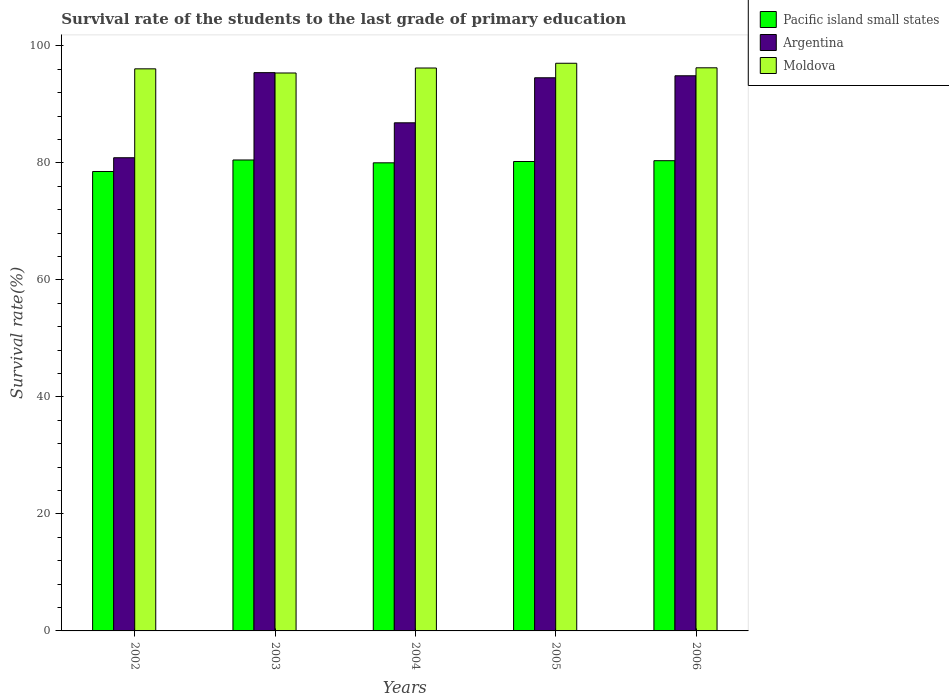How many different coloured bars are there?
Give a very brief answer. 3. Are the number of bars on each tick of the X-axis equal?
Your response must be concise. Yes. How many bars are there on the 3rd tick from the right?
Make the answer very short. 3. What is the label of the 2nd group of bars from the left?
Provide a short and direct response. 2003. In how many cases, is the number of bars for a given year not equal to the number of legend labels?
Offer a terse response. 0. What is the survival rate of the students in Pacific island small states in 2005?
Offer a very short reply. 80.23. Across all years, what is the maximum survival rate of the students in Argentina?
Keep it short and to the point. 95.42. Across all years, what is the minimum survival rate of the students in Moldova?
Give a very brief answer. 95.36. What is the total survival rate of the students in Moldova in the graph?
Ensure brevity in your answer.  480.9. What is the difference between the survival rate of the students in Argentina in 2003 and that in 2004?
Offer a very short reply. 8.57. What is the difference between the survival rate of the students in Argentina in 2003 and the survival rate of the students in Moldova in 2006?
Keep it short and to the point. -0.83. What is the average survival rate of the students in Pacific island small states per year?
Make the answer very short. 79.92. In the year 2005, what is the difference between the survival rate of the students in Moldova and survival rate of the students in Argentina?
Provide a short and direct response. 2.48. What is the ratio of the survival rate of the students in Pacific island small states in 2004 to that in 2005?
Your response must be concise. 1. Is the survival rate of the students in Pacific island small states in 2003 less than that in 2005?
Your answer should be compact. No. What is the difference between the highest and the second highest survival rate of the students in Argentina?
Your answer should be very brief. 0.53. What is the difference between the highest and the lowest survival rate of the students in Moldova?
Give a very brief answer. 1.66. In how many years, is the survival rate of the students in Pacific island small states greater than the average survival rate of the students in Pacific island small states taken over all years?
Your response must be concise. 4. What does the 1st bar from the left in 2006 represents?
Provide a short and direct response. Pacific island small states. What does the 2nd bar from the right in 2003 represents?
Offer a terse response. Argentina. Is it the case that in every year, the sum of the survival rate of the students in Argentina and survival rate of the students in Pacific island small states is greater than the survival rate of the students in Moldova?
Offer a very short reply. Yes. How many years are there in the graph?
Your answer should be very brief. 5. What is the difference between two consecutive major ticks on the Y-axis?
Your response must be concise. 20. Are the values on the major ticks of Y-axis written in scientific E-notation?
Provide a short and direct response. No. Does the graph contain any zero values?
Your response must be concise. No. Does the graph contain grids?
Your answer should be compact. No. Where does the legend appear in the graph?
Ensure brevity in your answer.  Top right. How many legend labels are there?
Offer a very short reply. 3. What is the title of the graph?
Give a very brief answer. Survival rate of the students to the last grade of primary education. What is the label or title of the Y-axis?
Your answer should be compact. Survival rate(%). What is the Survival rate(%) in Pacific island small states in 2002?
Your response must be concise. 78.52. What is the Survival rate(%) of Argentina in 2002?
Give a very brief answer. 80.87. What is the Survival rate(%) of Moldova in 2002?
Keep it short and to the point. 96.07. What is the Survival rate(%) of Pacific island small states in 2003?
Offer a very short reply. 80.49. What is the Survival rate(%) of Argentina in 2003?
Make the answer very short. 95.42. What is the Survival rate(%) of Moldova in 2003?
Make the answer very short. 95.36. What is the Survival rate(%) in Pacific island small states in 2004?
Provide a succinct answer. 80. What is the Survival rate(%) of Argentina in 2004?
Make the answer very short. 86.84. What is the Survival rate(%) of Moldova in 2004?
Offer a very short reply. 96.21. What is the Survival rate(%) in Pacific island small states in 2005?
Give a very brief answer. 80.23. What is the Survival rate(%) of Argentina in 2005?
Offer a terse response. 94.54. What is the Survival rate(%) of Moldova in 2005?
Provide a succinct answer. 97.02. What is the Survival rate(%) of Pacific island small states in 2006?
Offer a very short reply. 80.37. What is the Survival rate(%) in Argentina in 2006?
Provide a short and direct response. 94.88. What is the Survival rate(%) of Moldova in 2006?
Ensure brevity in your answer.  96.24. Across all years, what is the maximum Survival rate(%) in Pacific island small states?
Your answer should be compact. 80.49. Across all years, what is the maximum Survival rate(%) in Argentina?
Offer a terse response. 95.42. Across all years, what is the maximum Survival rate(%) in Moldova?
Offer a very short reply. 97.02. Across all years, what is the minimum Survival rate(%) in Pacific island small states?
Offer a very short reply. 78.52. Across all years, what is the minimum Survival rate(%) in Argentina?
Give a very brief answer. 80.87. Across all years, what is the minimum Survival rate(%) in Moldova?
Ensure brevity in your answer.  95.36. What is the total Survival rate(%) in Pacific island small states in the graph?
Ensure brevity in your answer.  399.61. What is the total Survival rate(%) in Argentina in the graph?
Make the answer very short. 452.55. What is the total Survival rate(%) of Moldova in the graph?
Your response must be concise. 480.9. What is the difference between the Survival rate(%) in Pacific island small states in 2002 and that in 2003?
Give a very brief answer. -1.97. What is the difference between the Survival rate(%) in Argentina in 2002 and that in 2003?
Your answer should be compact. -14.54. What is the difference between the Survival rate(%) of Moldova in 2002 and that in 2003?
Provide a short and direct response. 0.71. What is the difference between the Survival rate(%) of Pacific island small states in 2002 and that in 2004?
Offer a very short reply. -1.48. What is the difference between the Survival rate(%) in Argentina in 2002 and that in 2004?
Give a very brief answer. -5.97. What is the difference between the Survival rate(%) in Moldova in 2002 and that in 2004?
Make the answer very short. -0.14. What is the difference between the Survival rate(%) in Pacific island small states in 2002 and that in 2005?
Your answer should be very brief. -1.71. What is the difference between the Survival rate(%) in Argentina in 2002 and that in 2005?
Your answer should be very brief. -13.67. What is the difference between the Survival rate(%) of Moldova in 2002 and that in 2005?
Provide a short and direct response. -0.95. What is the difference between the Survival rate(%) of Pacific island small states in 2002 and that in 2006?
Keep it short and to the point. -1.84. What is the difference between the Survival rate(%) of Argentina in 2002 and that in 2006?
Your answer should be very brief. -14.01. What is the difference between the Survival rate(%) of Moldova in 2002 and that in 2006?
Provide a short and direct response. -0.17. What is the difference between the Survival rate(%) of Pacific island small states in 2003 and that in 2004?
Ensure brevity in your answer.  0.48. What is the difference between the Survival rate(%) of Argentina in 2003 and that in 2004?
Offer a terse response. 8.57. What is the difference between the Survival rate(%) of Moldova in 2003 and that in 2004?
Ensure brevity in your answer.  -0.85. What is the difference between the Survival rate(%) in Pacific island small states in 2003 and that in 2005?
Give a very brief answer. 0.26. What is the difference between the Survival rate(%) of Argentina in 2003 and that in 2005?
Your answer should be compact. 0.88. What is the difference between the Survival rate(%) of Moldova in 2003 and that in 2005?
Offer a terse response. -1.66. What is the difference between the Survival rate(%) in Pacific island small states in 2003 and that in 2006?
Provide a short and direct response. 0.12. What is the difference between the Survival rate(%) in Argentina in 2003 and that in 2006?
Give a very brief answer. 0.53. What is the difference between the Survival rate(%) of Moldova in 2003 and that in 2006?
Provide a succinct answer. -0.89. What is the difference between the Survival rate(%) in Pacific island small states in 2004 and that in 2005?
Make the answer very short. -0.22. What is the difference between the Survival rate(%) in Argentina in 2004 and that in 2005?
Your answer should be very brief. -7.7. What is the difference between the Survival rate(%) of Moldova in 2004 and that in 2005?
Keep it short and to the point. -0.81. What is the difference between the Survival rate(%) in Pacific island small states in 2004 and that in 2006?
Keep it short and to the point. -0.36. What is the difference between the Survival rate(%) of Argentina in 2004 and that in 2006?
Provide a succinct answer. -8.04. What is the difference between the Survival rate(%) of Moldova in 2004 and that in 2006?
Your response must be concise. -0.03. What is the difference between the Survival rate(%) in Pacific island small states in 2005 and that in 2006?
Offer a terse response. -0.14. What is the difference between the Survival rate(%) in Argentina in 2005 and that in 2006?
Make the answer very short. -0.34. What is the difference between the Survival rate(%) in Moldova in 2005 and that in 2006?
Ensure brevity in your answer.  0.78. What is the difference between the Survival rate(%) in Pacific island small states in 2002 and the Survival rate(%) in Argentina in 2003?
Your answer should be very brief. -16.89. What is the difference between the Survival rate(%) in Pacific island small states in 2002 and the Survival rate(%) in Moldova in 2003?
Offer a terse response. -16.84. What is the difference between the Survival rate(%) of Argentina in 2002 and the Survival rate(%) of Moldova in 2003?
Offer a terse response. -14.48. What is the difference between the Survival rate(%) in Pacific island small states in 2002 and the Survival rate(%) in Argentina in 2004?
Provide a short and direct response. -8.32. What is the difference between the Survival rate(%) of Pacific island small states in 2002 and the Survival rate(%) of Moldova in 2004?
Your answer should be compact. -17.69. What is the difference between the Survival rate(%) of Argentina in 2002 and the Survival rate(%) of Moldova in 2004?
Your answer should be compact. -15.34. What is the difference between the Survival rate(%) of Pacific island small states in 2002 and the Survival rate(%) of Argentina in 2005?
Give a very brief answer. -16.02. What is the difference between the Survival rate(%) in Pacific island small states in 2002 and the Survival rate(%) in Moldova in 2005?
Provide a succinct answer. -18.5. What is the difference between the Survival rate(%) of Argentina in 2002 and the Survival rate(%) of Moldova in 2005?
Provide a short and direct response. -16.15. What is the difference between the Survival rate(%) in Pacific island small states in 2002 and the Survival rate(%) in Argentina in 2006?
Ensure brevity in your answer.  -16.36. What is the difference between the Survival rate(%) in Pacific island small states in 2002 and the Survival rate(%) in Moldova in 2006?
Your answer should be compact. -17.72. What is the difference between the Survival rate(%) in Argentina in 2002 and the Survival rate(%) in Moldova in 2006?
Keep it short and to the point. -15.37. What is the difference between the Survival rate(%) in Pacific island small states in 2003 and the Survival rate(%) in Argentina in 2004?
Give a very brief answer. -6.35. What is the difference between the Survival rate(%) in Pacific island small states in 2003 and the Survival rate(%) in Moldova in 2004?
Make the answer very short. -15.72. What is the difference between the Survival rate(%) of Argentina in 2003 and the Survival rate(%) of Moldova in 2004?
Your answer should be very brief. -0.79. What is the difference between the Survival rate(%) of Pacific island small states in 2003 and the Survival rate(%) of Argentina in 2005?
Give a very brief answer. -14.05. What is the difference between the Survival rate(%) in Pacific island small states in 2003 and the Survival rate(%) in Moldova in 2005?
Provide a short and direct response. -16.53. What is the difference between the Survival rate(%) of Argentina in 2003 and the Survival rate(%) of Moldova in 2005?
Provide a succinct answer. -1.6. What is the difference between the Survival rate(%) of Pacific island small states in 2003 and the Survival rate(%) of Argentina in 2006?
Offer a terse response. -14.39. What is the difference between the Survival rate(%) in Pacific island small states in 2003 and the Survival rate(%) in Moldova in 2006?
Ensure brevity in your answer.  -15.75. What is the difference between the Survival rate(%) of Argentina in 2003 and the Survival rate(%) of Moldova in 2006?
Ensure brevity in your answer.  -0.83. What is the difference between the Survival rate(%) in Pacific island small states in 2004 and the Survival rate(%) in Argentina in 2005?
Your answer should be very brief. -14.54. What is the difference between the Survival rate(%) in Pacific island small states in 2004 and the Survival rate(%) in Moldova in 2005?
Ensure brevity in your answer.  -17.02. What is the difference between the Survival rate(%) of Argentina in 2004 and the Survival rate(%) of Moldova in 2005?
Offer a very short reply. -10.18. What is the difference between the Survival rate(%) in Pacific island small states in 2004 and the Survival rate(%) in Argentina in 2006?
Provide a succinct answer. -14.88. What is the difference between the Survival rate(%) in Pacific island small states in 2004 and the Survival rate(%) in Moldova in 2006?
Provide a succinct answer. -16.24. What is the difference between the Survival rate(%) in Argentina in 2004 and the Survival rate(%) in Moldova in 2006?
Your answer should be compact. -9.4. What is the difference between the Survival rate(%) of Pacific island small states in 2005 and the Survival rate(%) of Argentina in 2006?
Ensure brevity in your answer.  -14.65. What is the difference between the Survival rate(%) in Pacific island small states in 2005 and the Survival rate(%) in Moldova in 2006?
Your answer should be compact. -16.02. What is the difference between the Survival rate(%) of Argentina in 2005 and the Survival rate(%) of Moldova in 2006?
Offer a terse response. -1.7. What is the average Survival rate(%) in Pacific island small states per year?
Your answer should be compact. 79.92. What is the average Survival rate(%) of Argentina per year?
Keep it short and to the point. 90.51. What is the average Survival rate(%) of Moldova per year?
Provide a succinct answer. 96.18. In the year 2002, what is the difference between the Survival rate(%) of Pacific island small states and Survival rate(%) of Argentina?
Provide a short and direct response. -2.35. In the year 2002, what is the difference between the Survival rate(%) in Pacific island small states and Survival rate(%) in Moldova?
Your response must be concise. -17.55. In the year 2002, what is the difference between the Survival rate(%) in Argentina and Survival rate(%) in Moldova?
Provide a short and direct response. -15.2. In the year 2003, what is the difference between the Survival rate(%) in Pacific island small states and Survival rate(%) in Argentina?
Provide a succinct answer. -14.93. In the year 2003, what is the difference between the Survival rate(%) in Pacific island small states and Survival rate(%) in Moldova?
Provide a succinct answer. -14.87. In the year 2003, what is the difference between the Survival rate(%) of Argentina and Survival rate(%) of Moldova?
Provide a short and direct response. 0.06. In the year 2004, what is the difference between the Survival rate(%) of Pacific island small states and Survival rate(%) of Argentina?
Give a very brief answer. -6.84. In the year 2004, what is the difference between the Survival rate(%) of Pacific island small states and Survival rate(%) of Moldova?
Give a very brief answer. -16.2. In the year 2004, what is the difference between the Survival rate(%) in Argentina and Survival rate(%) in Moldova?
Make the answer very short. -9.37. In the year 2005, what is the difference between the Survival rate(%) in Pacific island small states and Survival rate(%) in Argentina?
Provide a succinct answer. -14.31. In the year 2005, what is the difference between the Survival rate(%) of Pacific island small states and Survival rate(%) of Moldova?
Provide a succinct answer. -16.79. In the year 2005, what is the difference between the Survival rate(%) in Argentina and Survival rate(%) in Moldova?
Provide a short and direct response. -2.48. In the year 2006, what is the difference between the Survival rate(%) of Pacific island small states and Survival rate(%) of Argentina?
Your response must be concise. -14.52. In the year 2006, what is the difference between the Survival rate(%) in Pacific island small states and Survival rate(%) in Moldova?
Offer a terse response. -15.88. In the year 2006, what is the difference between the Survival rate(%) of Argentina and Survival rate(%) of Moldova?
Keep it short and to the point. -1.36. What is the ratio of the Survival rate(%) in Pacific island small states in 2002 to that in 2003?
Provide a succinct answer. 0.98. What is the ratio of the Survival rate(%) of Argentina in 2002 to that in 2003?
Offer a terse response. 0.85. What is the ratio of the Survival rate(%) in Moldova in 2002 to that in 2003?
Provide a succinct answer. 1.01. What is the ratio of the Survival rate(%) in Pacific island small states in 2002 to that in 2004?
Offer a very short reply. 0.98. What is the ratio of the Survival rate(%) in Argentina in 2002 to that in 2004?
Your answer should be very brief. 0.93. What is the ratio of the Survival rate(%) of Moldova in 2002 to that in 2004?
Keep it short and to the point. 1. What is the ratio of the Survival rate(%) in Pacific island small states in 2002 to that in 2005?
Make the answer very short. 0.98. What is the ratio of the Survival rate(%) of Argentina in 2002 to that in 2005?
Ensure brevity in your answer.  0.86. What is the ratio of the Survival rate(%) of Moldova in 2002 to that in 2005?
Make the answer very short. 0.99. What is the ratio of the Survival rate(%) in Pacific island small states in 2002 to that in 2006?
Offer a terse response. 0.98. What is the ratio of the Survival rate(%) of Argentina in 2002 to that in 2006?
Offer a very short reply. 0.85. What is the ratio of the Survival rate(%) of Argentina in 2003 to that in 2004?
Give a very brief answer. 1.1. What is the ratio of the Survival rate(%) in Moldova in 2003 to that in 2004?
Your answer should be very brief. 0.99. What is the ratio of the Survival rate(%) of Argentina in 2003 to that in 2005?
Provide a short and direct response. 1.01. What is the ratio of the Survival rate(%) of Moldova in 2003 to that in 2005?
Your answer should be very brief. 0.98. What is the ratio of the Survival rate(%) in Pacific island small states in 2003 to that in 2006?
Ensure brevity in your answer.  1. What is the ratio of the Survival rate(%) of Argentina in 2003 to that in 2006?
Provide a succinct answer. 1.01. What is the ratio of the Survival rate(%) in Pacific island small states in 2004 to that in 2005?
Ensure brevity in your answer.  1. What is the ratio of the Survival rate(%) of Argentina in 2004 to that in 2005?
Offer a very short reply. 0.92. What is the ratio of the Survival rate(%) in Argentina in 2004 to that in 2006?
Provide a short and direct response. 0.92. What is the ratio of the Survival rate(%) of Moldova in 2004 to that in 2006?
Ensure brevity in your answer.  1. What is the ratio of the Survival rate(%) of Pacific island small states in 2005 to that in 2006?
Ensure brevity in your answer.  1. What is the ratio of the Survival rate(%) of Moldova in 2005 to that in 2006?
Make the answer very short. 1.01. What is the difference between the highest and the second highest Survival rate(%) in Pacific island small states?
Your answer should be compact. 0.12. What is the difference between the highest and the second highest Survival rate(%) in Argentina?
Offer a terse response. 0.53. What is the difference between the highest and the lowest Survival rate(%) in Pacific island small states?
Give a very brief answer. 1.97. What is the difference between the highest and the lowest Survival rate(%) of Argentina?
Keep it short and to the point. 14.54. What is the difference between the highest and the lowest Survival rate(%) of Moldova?
Provide a succinct answer. 1.66. 